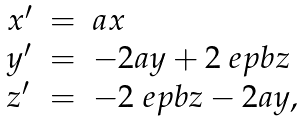Convert formula to latex. <formula><loc_0><loc_0><loc_500><loc_500>\begin{array} { l l l } x ^ { \prime } & = & a x \\ y ^ { \prime } & = & - 2 a y + 2 \ e p b z \\ z ^ { \prime } & = & - 2 \ e p b z - 2 a y , \end{array}</formula> 